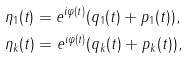Convert formula to latex. <formula><loc_0><loc_0><loc_500><loc_500>& \eta _ { 1 } ( t ) = e ^ { i \varphi ( t ) } ( q _ { 1 } ( t ) + p _ { 1 } ( t ) ) , \\ & \eta _ { k } ( t ) = e ^ { i \varphi ( t ) } ( q _ { k } ( t ) + p _ { k } ( t ) ) ,</formula> 